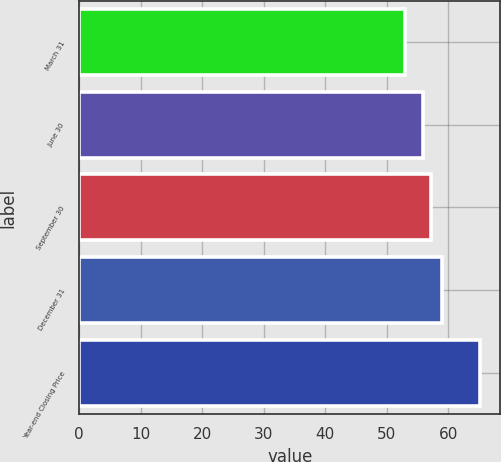<chart> <loc_0><loc_0><loc_500><loc_500><bar_chart><fcel>March 31<fcel>June 30<fcel>September 30<fcel>December 31<fcel>Year-end Closing Price<nl><fcel>53.04<fcel>55.87<fcel>57.25<fcel>58.96<fcel>65.21<nl></chart> 